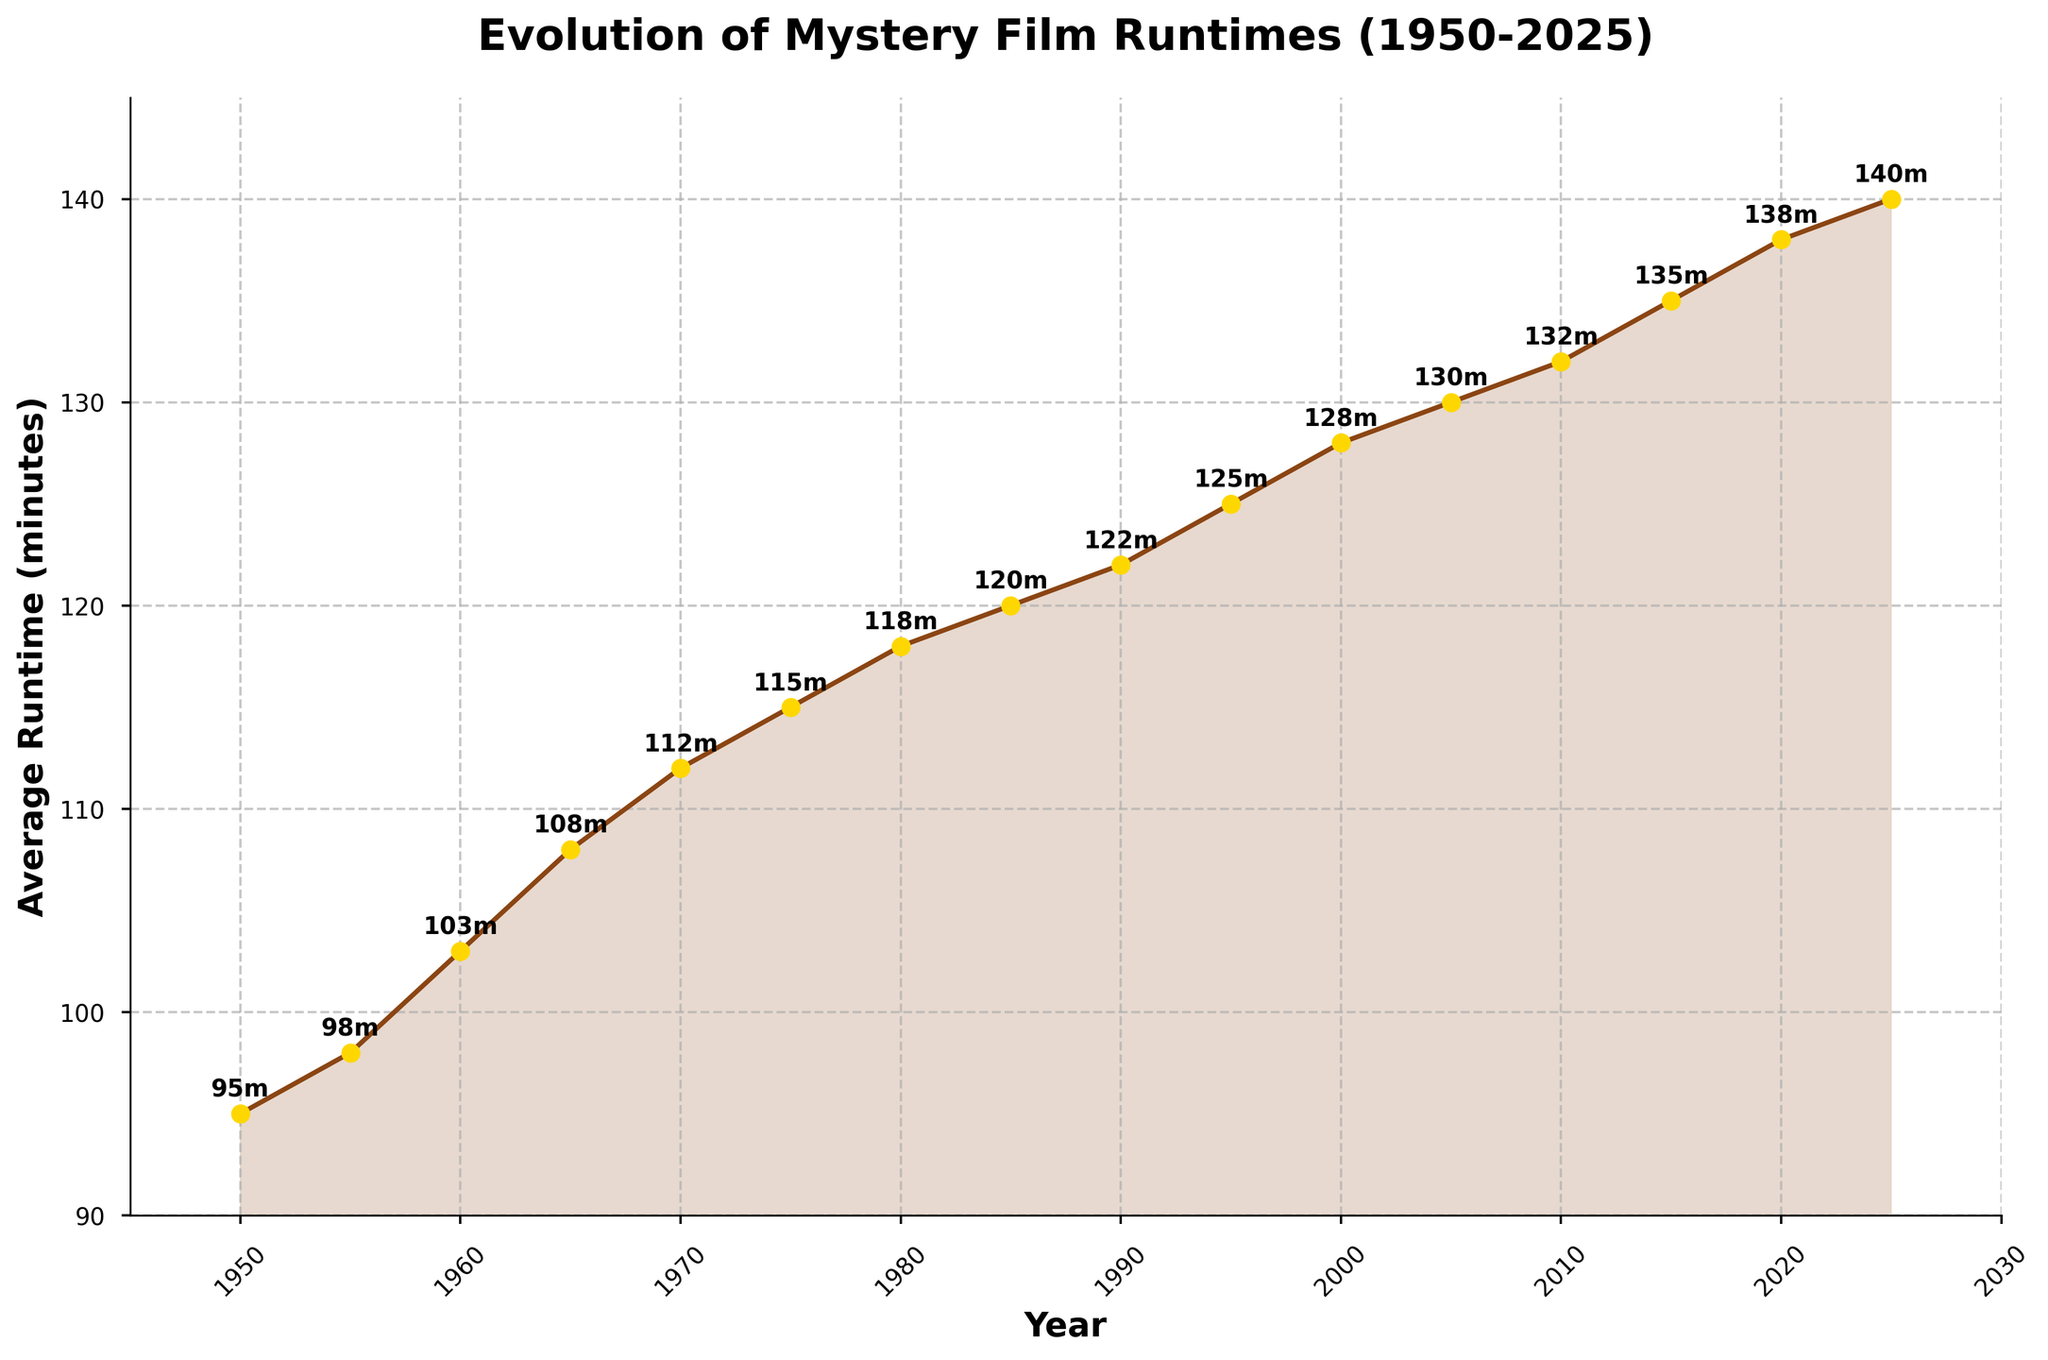What's the average runtime of mystery films in the 21st century (2000-2025)? The values for the years 2000, 2005, 2010, 2015, 2020, and 2025 are 128, 130, 132, 135, 138, and 140 minutes respectively. Sum these values and then divide by the number of years to find the average: (128 + 130 + 132 + 135 + 138 + 140) / 6 = 803 / 6 = 133.83 minutes
Answer: 133.83 minutes Which decade saw the greatest increase in the average runtime of mystery films? Observe the values for each decade and calculate the difference. For example, from 1950 to 1960, the increase is 103 - 95 = 8 minutes. Similarly,
1950-1960: 8 minutes
1960-1970: 112 - 103 = 9 minutes
1970-1980: 118 - 112 = 6 minutes
1980-1990: 122 - 118 = 4 minutes
1990-2000: 128 - 122 = 6 minutes
2000-2010: 132 - 128 = 4 minutes
2010-2020: 138 - 132 = 6 minutes.
The greatest increase occurred between 1960 to 1970 with a rise of 9 minutes.
Answer: 1960-1970 Which year had the shortest average runtime of mystery films? The lowest point on the y-axis corresponds to the year 1950 with an average runtime of 95 minutes.
Answer: 1950 How does the runtime of 2005 compare to the runtime of 2015? Locate the markers for 2005 and 2015 on the line. The average runtime in 2005 is 130 minutes and in 2015 is 135 minutes. The runtime in 2015 is greater than in 2005 by 5 minutes.
Answer: 2015 is 5 minutes longer By what percentage did the average runtime increase from 1950 to 2025? Calculate the percentage increase from 1950 (95 minutes) to 2025 (140 minutes): 
Percentage increase = ((140 - 95) / 95) * 100 = (45 / 95) * 100 ≈ 47.37%
Answer: Approximately 47.37% Is there any year between 1950 and 2025 where the average runtime decreased compared to the previous year? Examining the trend line, each subsequent year shows an increase or at least no decrease in runtime, so there is no year where the runtime decreased.
Answer: No What is the visual impact of the line color and markers in the chart? The brown line with golden markers makes the trend of increasing runtimes visually prominent and the filled area beneath the line emphasizes the growth over time.
Answer: Enhances trend visibility What's the difference in average runtime between 1950 and 2000? Subtract the average runtime of 1950 (95 min) from that of 2000 (128 min): 128 - 95 = 33 minutes.
Answer: 33 minutes How much did the average runtime change during the 1970s? The average runtime in 1970 is 112 minutes, and in 1980 is 118 minutes. The change is 118 - 112 = 6 minutes.
Answer: 6 minutes 